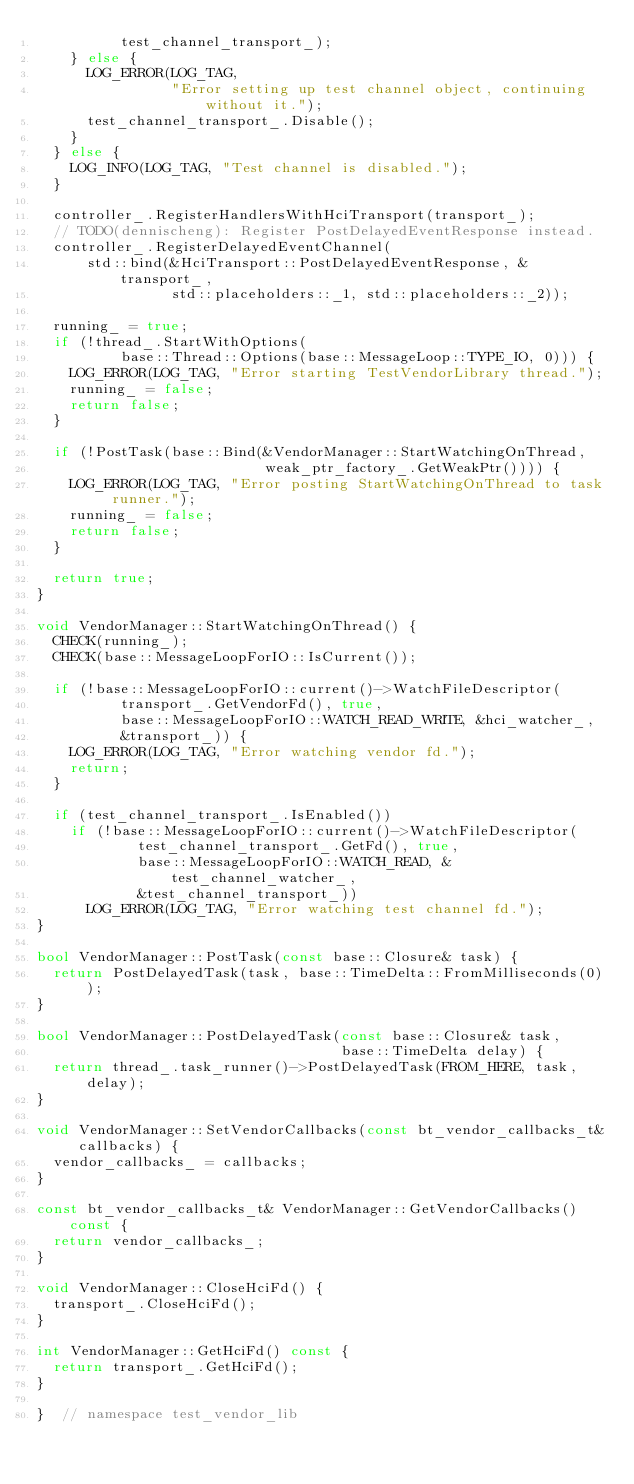<code> <loc_0><loc_0><loc_500><loc_500><_C++_>          test_channel_transport_);
    } else {
      LOG_ERROR(LOG_TAG,
                "Error setting up test channel object, continuing without it.");
      test_channel_transport_.Disable();
    }
  } else {
    LOG_INFO(LOG_TAG, "Test channel is disabled.");
  }

  controller_.RegisterHandlersWithHciTransport(transport_);
  // TODO(dennischeng): Register PostDelayedEventResponse instead.
  controller_.RegisterDelayedEventChannel(
      std::bind(&HciTransport::PostDelayedEventResponse, &transport_,
                std::placeholders::_1, std::placeholders::_2));

  running_ = true;
  if (!thread_.StartWithOptions(
          base::Thread::Options(base::MessageLoop::TYPE_IO, 0))) {
    LOG_ERROR(LOG_TAG, "Error starting TestVendorLibrary thread.");
    running_ = false;
    return false;
  }

  if (!PostTask(base::Bind(&VendorManager::StartWatchingOnThread,
                           weak_ptr_factory_.GetWeakPtr()))) {
    LOG_ERROR(LOG_TAG, "Error posting StartWatchingOnThread to task runner.");
    running_ = false;
    return false;
  }

  return true;
}

void VendorManager::StartWatchingOnThread() {
  CHECK(running_);
  CHECK(base::MessageLoopForIO::IsCurrent());

  if (!base::MessageLoopForIO::current()->WatchFileDescriptor(
          transport_.GetVendorFd(), true,
          base::MessageLoopForIO::WATCH_READ_WRITE, &hci_watcher_,
          &transport_)) {
    LOG_ERROR(LOG_TAG, "Error watching vendor fd.");
    return;
  }

  if (test_channel_transport_.IsEnabled())
    if (!base::MessageLoopForIO::current()->WatchFileDescriptor(
            test_channel_transport_.GetFd(), true,
            base::MessageLoopForIO::WATCH_READ, &test_channel_watcher_,
            &test_channel_transport_))
      LOG_ERROR(LOG_TAG, "Error watching test channel fd.");
}

bool VendorManager::PostTask(const base::Closure& task) {
  return PostDelayedTask(task, base::TimeDelta::FromMilliseconds(0));
}

bool VendorManager::PostDelayedTask(const base::Closure& task,
                                    base::TimeDelta delay) {
  return thread_.task_runner()->PostDelayedTask(FROM_HERE, task, delay);
}

void VendorManager::SetVendorCallbacks(const bt_vendor_callbacks_t& callbacks) {
  vendor_callbacks_ = callbacks;
}

const bt_vendor_callbacks_t& VendorManager::GetVendorCallbacks() const {
  return vendor_callbacks_;
}

void VendorManager::CloseHciFd() {
  transport_.CloseHciFd();
}

int VendorManager::GetHciFd() const {
  return transport_.GetHciFd();
}

}  // namespace test_vendor_lib
</code> 